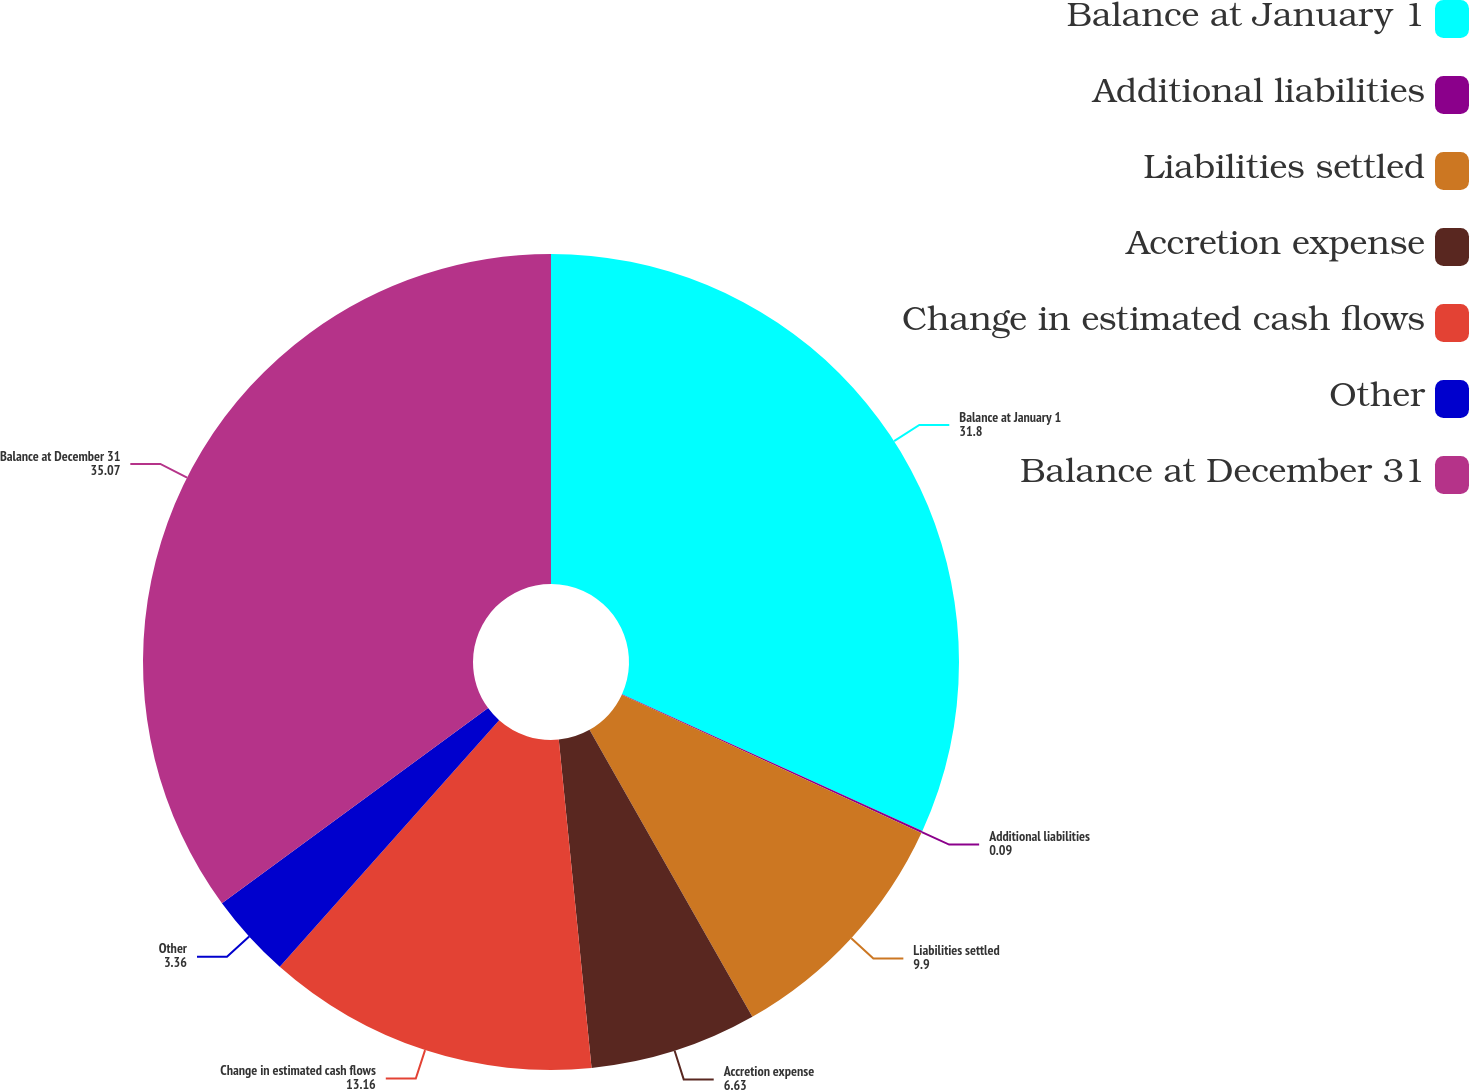<chart> <loc_0><loc_0><loc_500><loc_500><pie_chart><fcel>Balance at January 1<fcel>Additional liabilities<fcel>Liabilities settled<fcel>Accretion expense<fcel>Change in estimated cash flows<fcel>Other<fcel>Balance at December 31<nl><fcel>31.8%<fcel>0.09%<fcel>9.9%<fcel>6.63%<fcel>13.16%<fcel>3.36%<fcel>35.07%<nl></chart> 